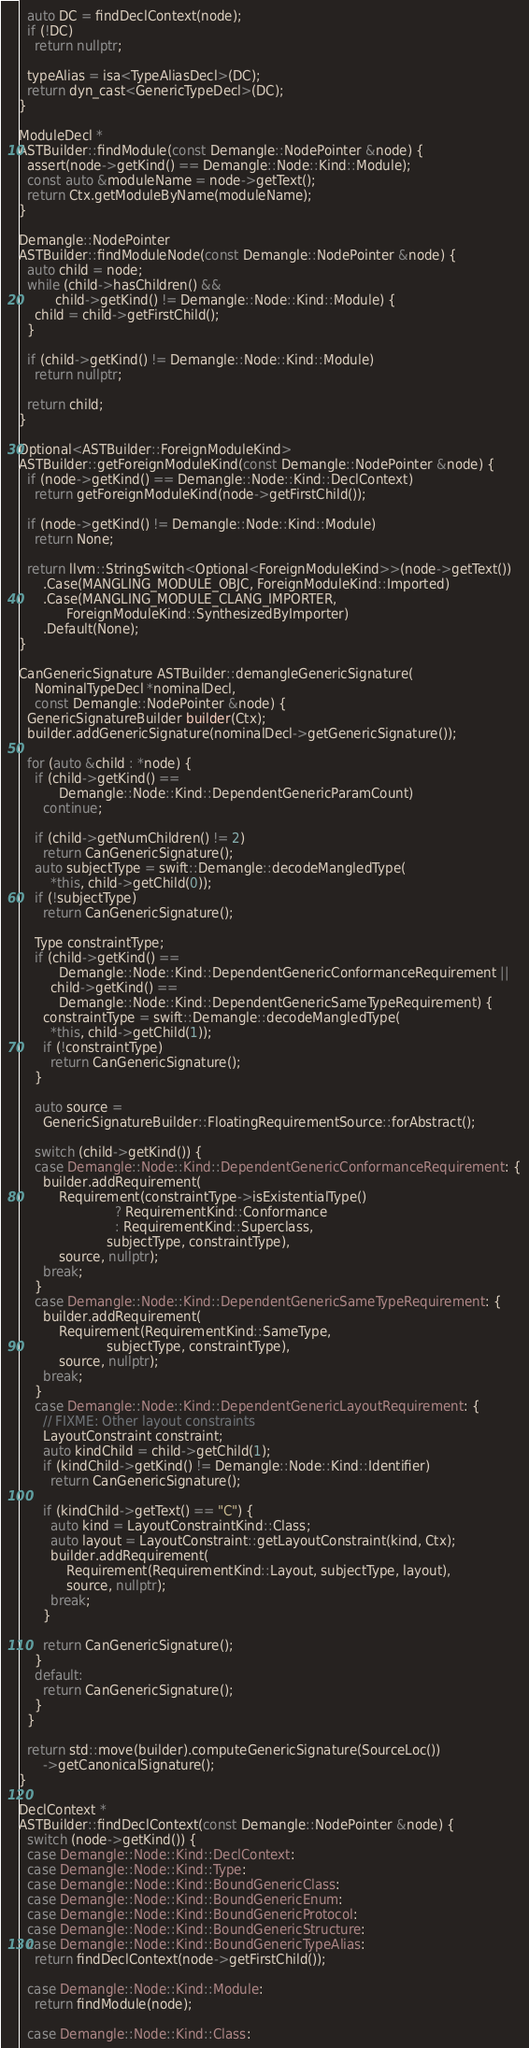Convert code to text. <code><loc_0><loc_0><loc_500><loc_500><_C++_>  auto DC = findDeclContext(node);
  if (!DC)
    return nullptr;

  typeAlias = isa<TypeAliasDecl>(DC);
  return dyn_cast<GenericTypeDecl>(DC);
}

ModuleDecl *
ASTBuilder::findModule(const Demangle::NodePointer &node) {
  assert(node->getKind() == Demangle::Node::Kind::Module);
  const auto &moduleName = node->getText();
  return Ctx.getModuleByName(moduleName);
}

Demangle::NodePointer
ASTBuilder::findModuleNode(const Demangle::NodePointer &node) {
  auto child = node;
  while (child->hasChildren() &&
         child->getKind() != Demangle::Node::Kind::Module) {
    child = child->getFirstChild();
  }

  if (child->getKind() != Demangle::Node::Kind::Module)
    return nullptr;

  return child;
}

Optional<ASTBuilder::ForeignModuleKind>
ASTBuilder::getForeignModuleKind(const Demangle::NodePointer &node) {
  if (node->getKind() == Demangle::Node::Kind::DeclContext)
    return getForeignModuleKind(node->getFirstChild());

  if (node->getKind() != Demangle::Node::Kind::Module)
    return None;

  return llvm::StringSwitch<Optional<ForeignModuleKind>>(node->getText())
      .Case(MANGLING_MODULE_OBJC, ForeignModuleKind::Imported)
      .Case(MANGLING_MODULE_CLANG_IMPORTER,
            ForeignModuleKind::SynthesizedByImporter)
      .Default(None);
}

CanGenericSignature ASTBuilder::demangleGenericSignature(
    NominalTypeDecl *nominalDecl,
    const Demangle::NodePointer &node) {
  GenericSignatureBuilder builder(Ctx);
  builder.addGenericSignature(nominalDecl->getGenericSignature());

  for (auto &child : *node) {
    if (child->getKind() ==
          Demangle::Node::Kind::DependentGenericParamCount)
      continue;

    if (child->getNumChildren() != 2)
      return CanGenericSignature();
    auto subjectType = swift::Demangle::decodeMangledType(
        *this, child->getChild(0));
    if (!subjectType)
      return CanGenericSignature();

    Type constraintType;
    if (child->getKind() ==
          Demangle::Node::Kind::DependentGenericConformanceRequirement ||
        child->getKind() ==
          Demangle::Node::Kind::DependentGenericSameTypeRequirement) {
      constraintType = swift::Demangle::decodeMangledType(
        *this, child->getChild(1));
      if (!constraintType)
        return CanGenericSignature();
    }

    auto source =
      GenericSignatureBuilder::FloatingRequirementSource::forAbstract();

    switch (child->getKind()) {
    case Demangle::Node::Kind::DependentGenericConformanceRequirement: {
      builder.addRequirement(
          Requirement(constraintType->isExistentialType()
                        ? RequirementKind::Conformance
                        : RequirementKind::Superclass,
                      subjectType, constraintType),
          source, nullptr);
      break;
    }
    case Demangle::Node::Kind::DependentGenericSameTypeRequirement: {
      builder.addRequirement(
          Requirement(RequirementKind::SameType,
                      subjectType, constraintType),
          source, nullptr);
      break;
    }
    case Demangle::Node::Kind::DependentGenericLayoutRequirement: {
      // FIXME: Other layout constraints
      LayoutConstraint constraint;
      auto kindChild = child->getChild(1);
      if (kindChild->getKind() != Demangle::Node::Kind::Identifier)
        return CanGenericSignature();

      if (kindChild->getText() == "C") {
        auto kind = LayoutConstraintKind::Class;
        auto layout = LayoutConstraint::getLayoutConstraint(kind, Ctx);
        builder.addRequirement(
            Requirement(RequirementKind::Layout, subjectType, layout),
            source, nullptr);
        break;
      }

      return CanGenericSignature();
    }
    default:
      return CanGenericSignature();
    }
  }

  return std::move(builder).computeGenericSignature(SourceLoc())
      ->getCanonicalSignature();
}

DeclContext *
ASTBuilder::findDeclContext(const Demangle::NodePointer &node) {
  switch (node->getKind()) {
  case Demangle::Node::Kind::DeclContext:
  case Demangle::Node::Kind::Type:
  case Demangle::Node::Kind::BoundGenericClass:
  case Demangle::Node::Kind::BoundGenericEnum:
  case Demangle::Node::Kind::BoundGenericProtocol:
  case Demangle::Node::Kind::BoundGenericStructure:
  case Demangle::Node::Kind::BoundGenericTypeAlias:
    return findDeclContext(node->getFirstChild());

  case Demangle::Node::Kind::Module:
    return findModule(node);

  case Demangle::Node::Kind::Class:</code> 